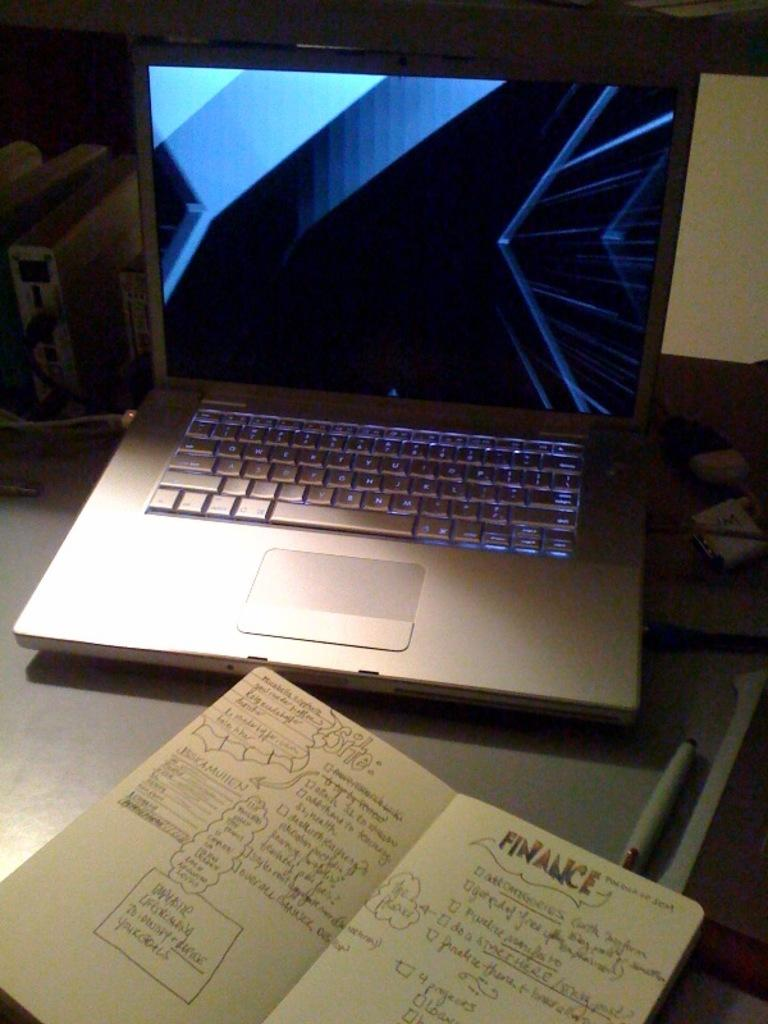<image>
Summarize the visual content of the image. a bullet journal sits on the desk that has information about "Finance" 